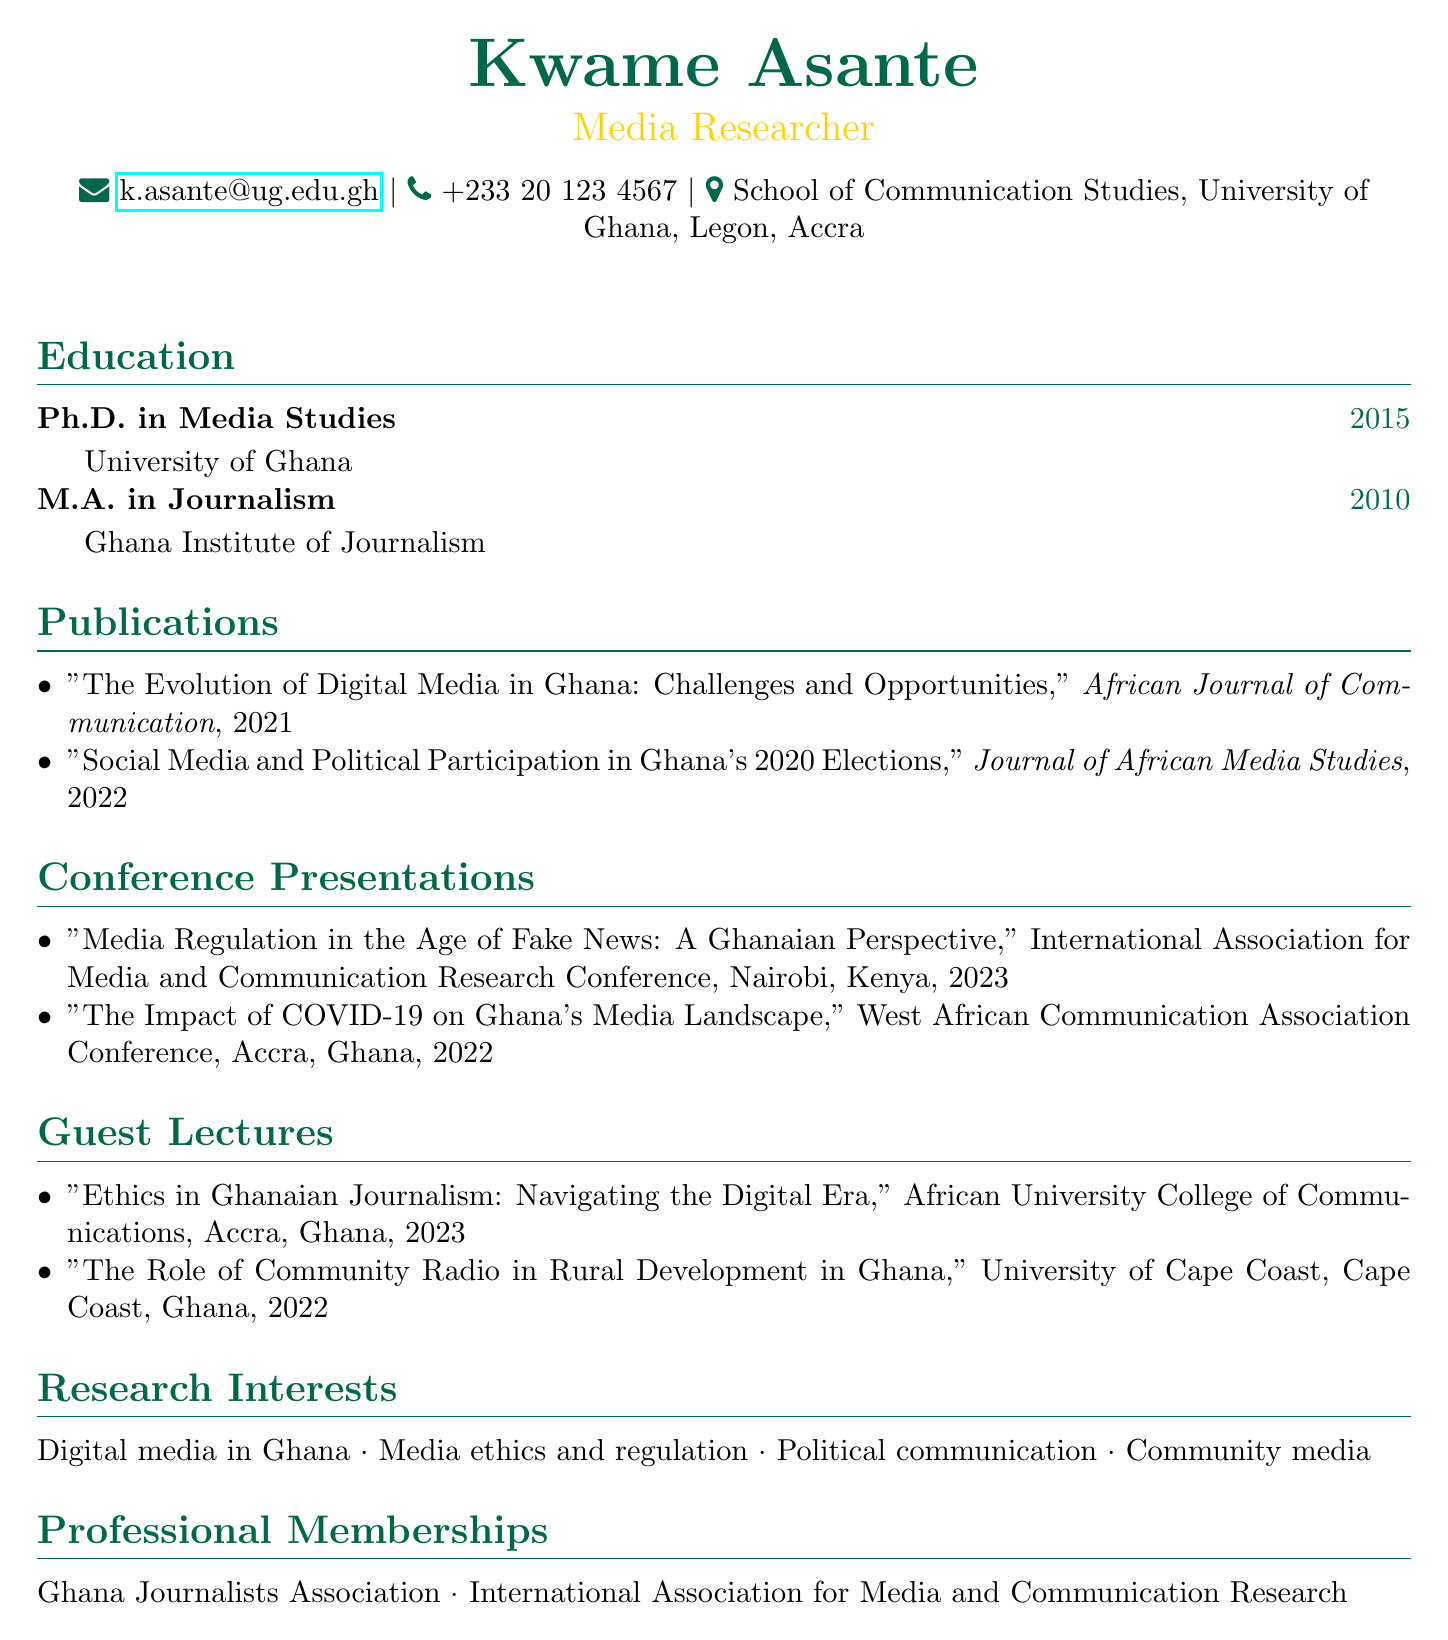what is the name of the researcher? The name of the researcher is presented as the first item in the document.
Answer: Kwame Asante what year did Kwame Asante complete his Ph.D.? The year of completion is listed under the education section, which mentions the Ph.D. degree.
Answer: 2015 which journal published the article on digital media in Ghana? The document specifies the journal associated with each publication.
Answer: African Journal of Communication what was the title of the conference presentation in 2023? The document lists the titles of conference presentations along with their respective years.
Answer: Media Regulation in the Age of Fake News: A Ghanaian Perspective how many guest lectures did Kwame Asante give? The information is found in the guest lectures section, which counts the entries.
Answer: 2 name one of Kwame Asante's research interests. Research interests are listed in a specific section of the document that delineates his areas of focus.
Answer: Digital media in Ghana where did the West African Communication Association Conference take place? The location of the conference is mentioned along with the title of the conference in the document.
Answer: Accra, Ghana which professional membership is associated with Kwame Asante? The memberships are explicitly listed in the document under the relevant section.
Answer: Ghana Journalists Association 